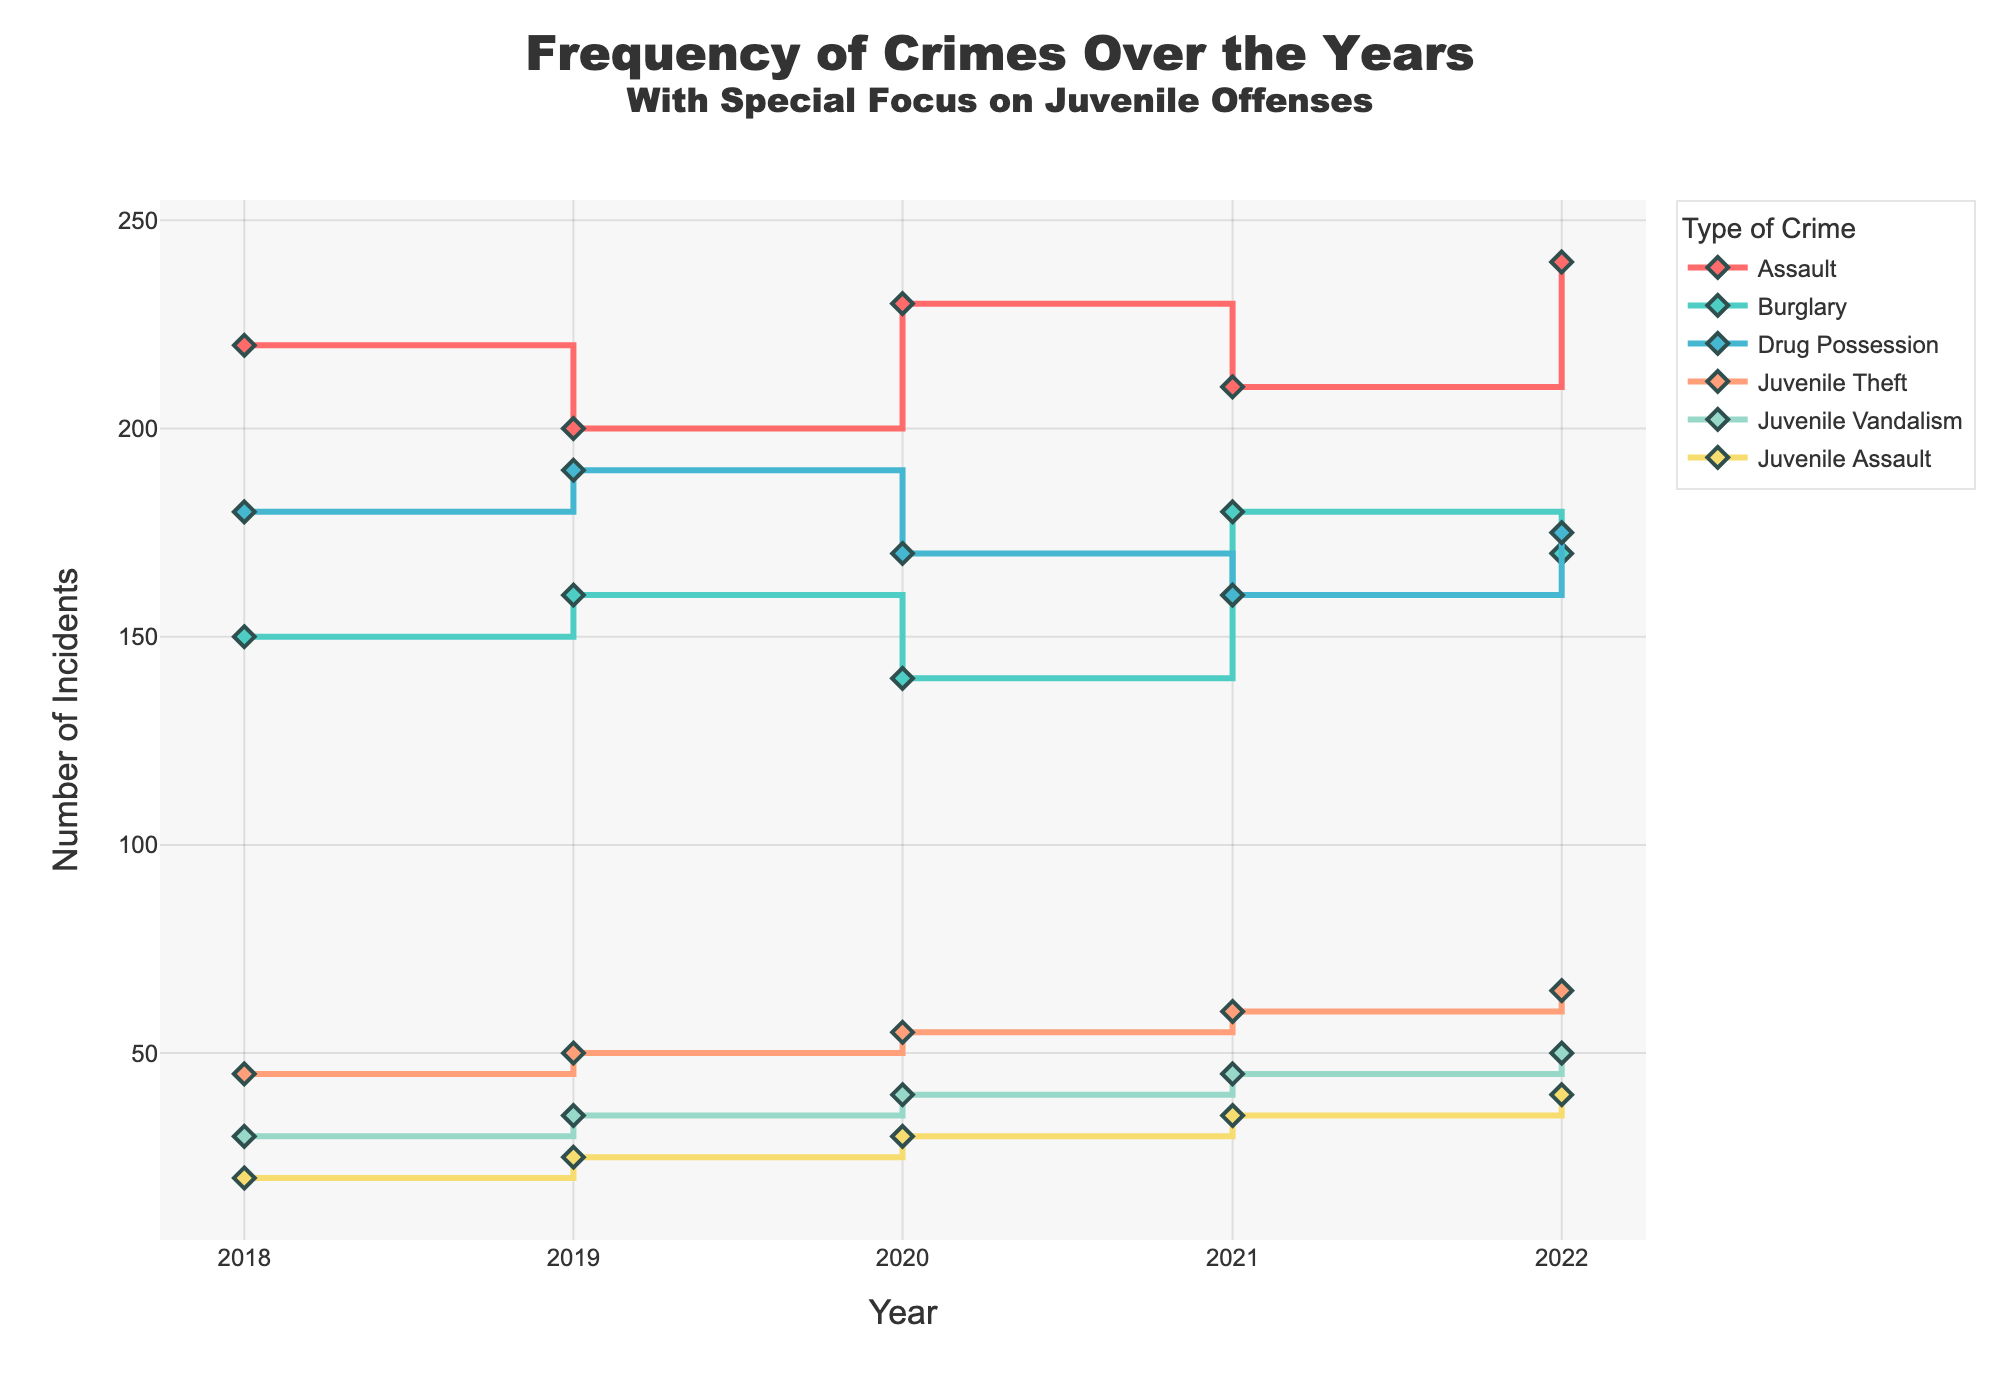What's the trend in the number of Juvenile Theft incidents from 2018 to 2022? The number of Juvenile Theft incidents increases each year in the timeframe observed. In 2018, there were 45 incidents, and by 2022, the number had grown to 65.
Answer: Increasing trend Which year had the highest number of Juvenile Assault incidents? To identify the highest number of Juvenile Assault incidents, observe the points on the Juvenile Assault line. The highest point on this line is in 2022 at 40 incidents.
Answer: 2022 How does the trend of Drug Possession incidents compare with that of Burglary incidents? Drug Possession incidents show a fluctuating trend but generally decrease from 2018 to 2021 before a slight rise in 2022. Burglary incidents show minor fluctuations but generally neither increase nor decrease significantly.
Answer: Drug Possession: generally decreasing, Burglary: relatively stable What is the difference in the count of Assault incidents between the years 2018 and 2022? To determine the difference, subtract the number of Assault incidents in 2018 (220) from that in 2022 (240). The difference is 20 incidents.
Answer: 20 incidents Which crime type shows the most consistent increase over the years? By observing the lines representing the types of crimes, Juvenile Theft shows a consistent increase each year without any decreases or significant fluctuations.
Answer: Juvenile Theft How many types of Juvenile crimes are tracked in this data, and what are they? There are three types of Juvenile crimes tracked: Juvenile Theft, Juvenile Vandalism, and Juvenile Assault, as indicated by the unique traces dedicated to these names.
Answer: Three types: Juvenile Theft, Juvenile Vandalism, Juvenile Assault Was there any year when Burglary incidents experienced a noticeable increase? Burglary incidents experienced noticeable increases in 2019 and 2021, when the count rose from 150 to 160 and from 140 to 180, respectively.
Answer: 2019 and 2021 On average, how many Juvenile Vandalism incidents occurred per year from 2018 to 2022? The yearly counts are: 30, 35, 40, 45, and 50. Sum these (30 + 35 + 40 + 45 + 50) to get 200 and divide by 5 years, resulting in an average of 40 incidents per year.
Answer: 40 incidents per year Which crime had the highest number of incidents every year between 2018 and 2022? By looking at the highest points for each year, Assault consistently has the highest number of incidents compared to other crimes each year.
Answer: Assault Are there any crime types that shown a decreasing trend over the years? By following the steps on the lines, Burglary incidents show a decreasing trend overall, particularly from 2020 to 2022.
Answer: Burglary 